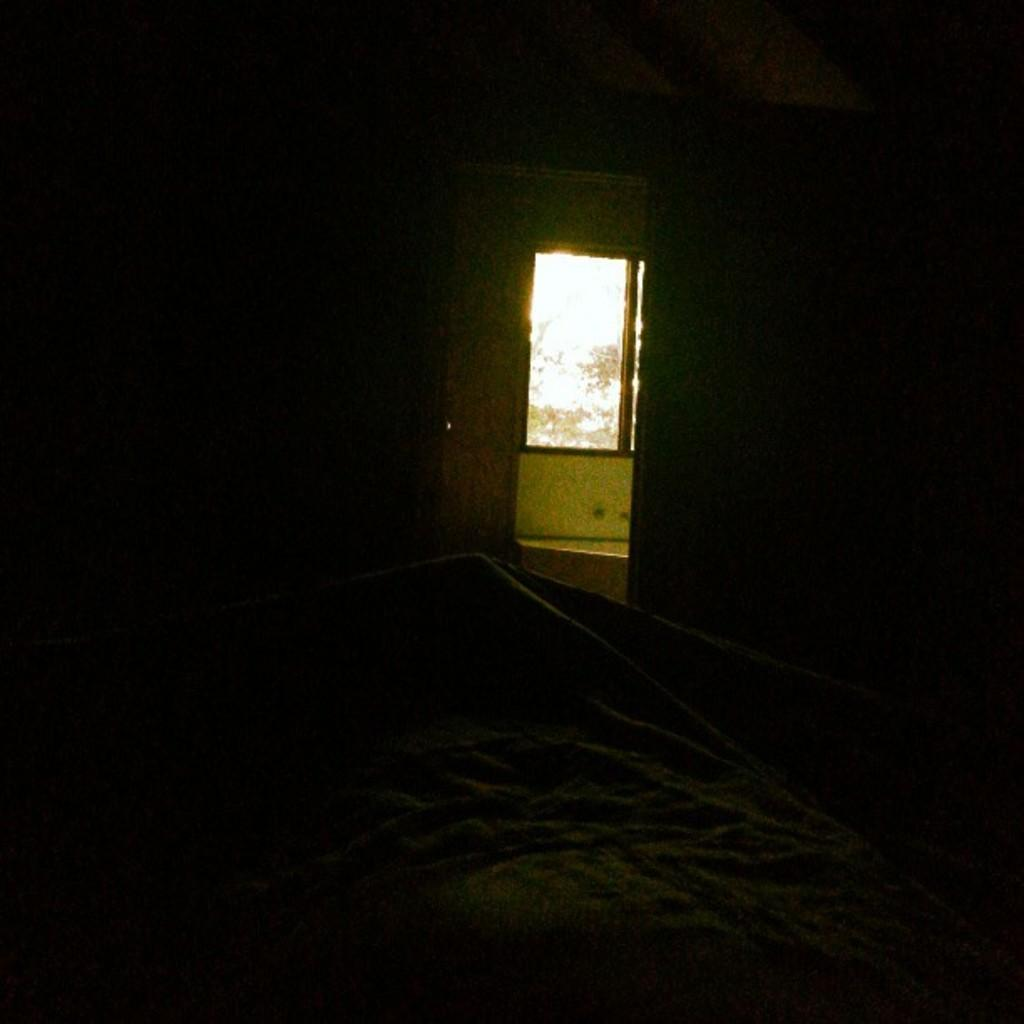What is the overall lighting condition in the image? The image is dark. What type of material can be seen in the image? There is cloth visible in the image. What can be seen in the background of the image? There is a wall and a glass window in the background of the image. What songs can be heard playing in the background of the image? There is no audio or indication of music in the image, so it is not possible to determine what songs might be heard. 